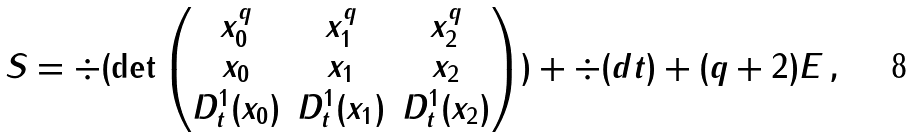<formula> <loc_0><loc_0><loc_500><loc_500>S = \div ( \det \begin{pmatrix} x _ { 0 } ^ { q } & x _ { 1 } ^ { q } & x _ { 2 } ^ { q } \\ x _ { 0 } & x _ { 1 } & x _ { 2 } \\ D ^ { 1 } _ { t } ( x _ { 0 } ) & D ^ { 1 } _ { t } ( x _ { 1 } ) & D ^ { 1 } _ { t } ( x _ { 2 } ) \end{pmatrix} ) + \div ( d t ) + ( q + 2 ) E \, ,</formula> 